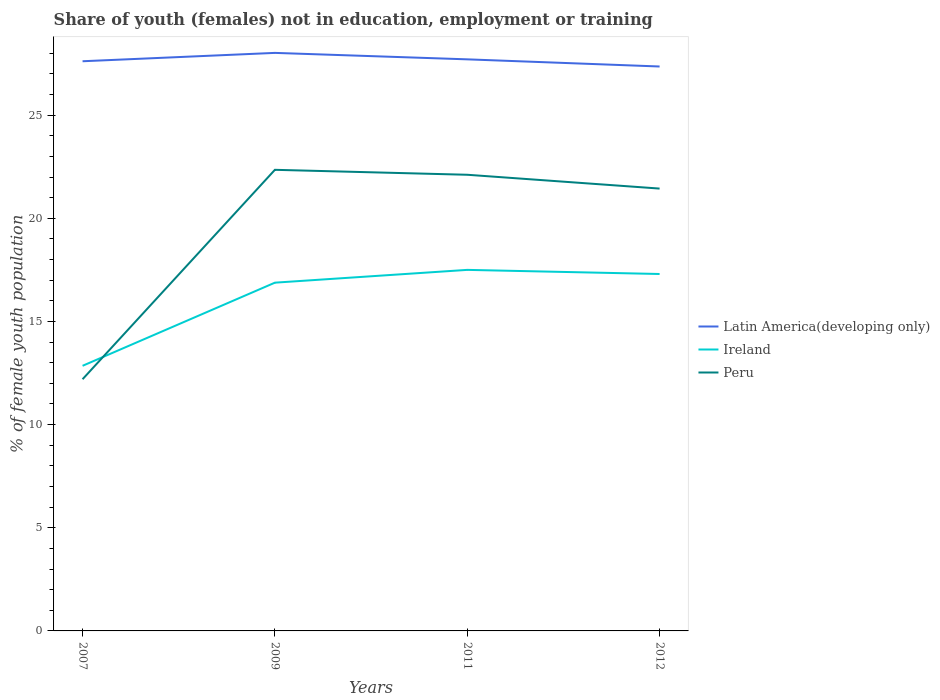Across all years, what is the maximum percentage of unemployed female population in in Ireland?
Your response must be concise. 12.85. What is the total percentage of unemployed female population in in Ireland in the graph?
Give a very brief answer. -4.45. What is the difference between the highest and the second highest percentage of unemployed female population in in Latin America(developing only)?
Give a very brief answer. 0.66. What is the difference between the highest and the lowest percentage of unemployed female population in in Ireland?
Make the answer very short. 3. How many lines are there?
Offer a terse response. 3. How many years are there in the graph?
Your answer should be very brief. 4. What is the difference between two consecutive major ticks on the Y-axis?
Ensure brevity in your answer.  5. Does the graph contain any zero values?
Keep it short and to the point. No. Where does the legend appear in the graph?
Provide a succinct answer. Center right. What is the title of the graph?
Your answer should be very brief. Share of youth (females) not in education, employment or training. What is the label or title of the Y-axis?
Provide a succinct answer. % of female youth population. What is the % of female youth population of Latin America(developing only) in 2007?
Provide a short and direct response. 27.61. What is the % of female youth population in Ireland in 2007?
Keep it short and to the point. 12.85. What is the % of female youth population in Peru in 2007?
Make the answer very short. 12.2. What is the % of female youth population in Latin America(developing only) in 2009?
Your answer should be compact. 28.02. What is the % of female youth population in Ireland in 2009?
Offer a terse response. 16.88. What is the % of female youth population of Peru in 2009?
Your response must be concise. 22.35. What is the % of female youth population in Latin America(developing only) in 2011?
Provide a succinct answer. 27.7. What is the % of female youth population of Ireland in 2011?
Your answer should be very brief. 17.5. What is the % of female youth population of Peru in 2011?
Offer a very short reply. 22.11. What is the % of female youth population in Latin America(developing only) in 2012?
Provide a short and direct response. 27.36. What is the % of female youth population of Ireland in 2012?
Your answer should be very brief. 17.3. What is the % of female youth population in Peru in 2012?
Provide a succinct answer. 21.44. Across all years, what is the maximum % of female youth population of Latin America(developing only)?
Your answer should be compact. 28.02. Across all years, what is the maximum % of female youth population in Peru?
Keep it short and to the point. 22.35. Across all years, what is the minimum % of female youth population of Latin America(developing only)?
Keep it short and to the point. 27.36. Across all years, what is the minimum % of female youth population in Ireland?
Keep it short and to the point. 12.85. Across all years, what is the minimum % of female youth population of Peru?
Keep it short and to the point. 12.2. What is the total % of female youth population of Latin America(developing only) in the graph?
Make the answer very short. 110.69. What is the total % of female youth population in Ireland in the graph?
Provide a short and direct response. 64.53. What is the total % of female youth population of Peru in the graph?
Your response must be concise. 78.1. What is the difference between the % of female youth population of Latin America(developing only) in 2007 and that in 2009?
Give a very brief answer. -0.4. What is the difference between the % of female youth population of Ireland in 2007 and that in 2009?
Keep it short and to the point. -4.03. What is the difference between the % of female youth population of Peru in 2007 and that in 2009?
Your response must be concise. -10.15. What is the difference between the % of female youth population of Latin America(developing only) in 2007 and that in 2011?
Keep it short and to the point. -0.09. What is the difference between the % of female youth population in Ireland in 2007 and that in 2011?
Provide a short and direct response. -4.65. What is the difference between the % of female youth population in Peru in 2007 and that in 2011?
Offer a terse response. -9.91. What is the difference between the % of female youth population in Latin America(developing only) in 2007 and that in 2012?
Your answer should be very brief. 0.25. What is the difference between the % of female youth population of Ireland in 2007 and that in 2012?
Your response must be concise. -4.45. What is the difference between the % of female youth population of Peru in 2007 and that in 2012?
Give a very brief answer. -9.24. What is the difference between the % of female youth population in Latin America(developing only) in 2009 and that in 2011?
Your answer should be very brief. 0.31. What is the difference between the % of female youth population of Ireland in 2009 and that in 2011?
Ensure brevity in your answer.  -0.62. What is the difference between the % of female youth population of Peru in 2009 and that in 2011?
Provide a short and direct response. 0.24. What is the difference between the % of female youth population in Latin America(developing only) in 2009 and that in 2012?
Provide a succinct answer. 0.66. What is the difference between the % of female youth population in Ireland in 2009 and that in 2012?
Give a very brief answer. -0.42. What is the difference between the % of female youth population in Peru in 2009 and that in 2012?
Give a very brief answer. 0.91. What is the difference between the % of female youth population of Latin America(developing only) in 2011 and that in 2012?
Your response must be concise. 0.35. What is the difference between the % of female youth population in Peru in 2011 and that in 2012?
Your response must be concise. 0.67. What is the difference between the % of female youth population in Latin America(developing only) in 2007 and the % of female youth population in Ireland in 2009?
Offer a terse response. 10.73. What is the difference between the % of female youth population of Latin America(developing only) in 2007 and the % of female youth population of Peru in 2009?
Keep it short and to the point. 5.26. What is the difference between the % of female youth population of Latin America(developing only) in 2007 and the % of female youth population of Ireland in 2011?
Ensure brevity in your answer.  10.11. What is the difference between the % of female youth population in Latin America(developing only) in 2007 and the % of female youth population in Peru in 2011?
Your answer should be compact. 5.5. What is the difference between the % of female youth population of Ireland in 2007 and the % of female youth population of Peru in 2011?
Offer a terse response. -9.26. What is the difference between the % of female youth population of Latin America(developing only) in 2007 and the % of female youth population of Ireland in 2012?
Your response must be concise. 10.31. What is the difference between the % of female youth population in Latin America(developing only) in 2007 and the % of female youth population in Peru in 2012?
Offer a terse response. 6.17. What is the difference between the % of female youth population in Ireland in 2007 and the % of female youth population in Peru in 2012?
Provide a succinct answer. -8.59. What is the difference between the % of female youth population of Latin America(developing only) in 2009 and the % of female youth population of Ireland in 2011?
Your answer should be very brief. 10.52. What is the difference between the % of female youth population in Latin America(developing only) in 2009 and the % of female youth population in Peru in 2011?
Your response must be concise. 5.91. What is the difference between the % of female youth population in Ireland in 2009 and the % of female youth population in Peru in 2011?
Give a very brief answer. -5.23. What is the difference between the % of female youth population of Latin America(developing only) in 2009 and the % of female youth population of Ireland in 2012?
Give a very brief answer. 10.72. What is the difference between the % of female youth population of Latin America(developing only) in 2009 and the % of female youth population of Peru in 2012?
Offer a very short reply. 6.58. What is the difference between the % of female youth population in Ireland in 2009 and the % of female youth population in Peru in 2012?
Your answer should be compact. -4.56. What is the difference between the % of female youth population of Latin America(developing only) in 2011 and the % of female youth population of Ireland in 2012?
Give a very brief answer. 10.4. What is the difference between the % of female youth population in Latin America(developing only) in 2011 and the % of female youth population in Peru in 2012?
Your answer should be compact. 6.26. What is the difference between the % of female youth population of Ireland in 2011 and the % of female youth population of Peru in 2012?
Your answer should be compact. -3.94. What is the average % of female youth population of Latin America(developing only) per year?
Your response must be concise. 27.67. What is the average % of female youth population in Ireland per year?
Offer a very short reply. 16.13. What is the average % of female youth population in Peru per year?
Ensure brevity in your answer.  19.52. In the year 2007, what is the difference between the % of female youth population of Latin America(developing only) and % of female youth population of Ireland?
Give a very brief answer. 14.76. In the year 2007, what is the difference between the % of female youth population of Latin America(developing only) and % of female youth population of Peru?
Your answer should be very brief. 15.41. In the year 2007, what is the difference between the % of female youth population of Ireland and % of female youth population of Peru?
Ensure brevity in your answer.  0.65. In the year 2009, what is the difference between the % of female youth population of Latin America(developing only) and % of female youth population of Ireland?
Offer a terse response. 11.14. In the year 2009, what is the difference between the % of female youth population in Latin America(developing only) and % of female youth population in Peru?
Provide a short and direct response. 5.67. In the year 2009, what is the difference between the % of female youth population in Ireland and % of female youth population in Peru?
Give a very brief answer. -5.47. In the year 2011, what is the difference between the % of female youth population in Latin America(developing only) and % of female youth population in Ireland?
Offer a very short reply. 10.2. In the year 2011, what is the difference between the % of female youth population of Latin America(developing only) and % of female youth population of Peru?
Give a very brief answer. 5.59. In the year 2011, what is the difference between the % of female youth population of Ireland and % of female youth population of Peru?
Provide a succinct answer. -4.61. In the year 2012, what is the difference between the % of female youth population in Latin America(developing only) and % of female youth population in Ireland?
Offer a very short reply. 10.06. In the year 2012, what is the difference between the % of female youth population in Latin America(developing only) and % of female youth population in Peru?
Your response must be concise. 5.92. In the year 2012, what is the difference between the % of female youth population in Ireland and % of female youth population in Peru?
Make the answer very short. -4.14. What is the ratio of the % of female youth population in Latin America(developing only) in 2007 to that in 2009?
Make the answer very short. 0.99. What is the ratio of the % of female youth population in Ireland in 2007 to that in 2009?
Provide a short and direct response. 0.76. What is the ratio of the % of female youth population in Peru in 2007 to that in 2009?
Your answer should be very brief. 0.55. What is the ratio of the % of female youth population in Ireland in 2007 to that in 2011?
Ensure brevity in your answer.  0.73. What is the ratio of the % of female youth population of Peru in 2007 to that in 2011?
Your response must be concise. 0.55. What is the ratio of the % of female youth population in Latin America(developing only) in 2007 to that in 2012?
Give a very brief answer. 1.01. What is the ratio of the % of female youth population of Ireland in 2007 to that in 2012?
Your response must be concise. 0.74. What is the ratio of the % of female youth population of Peru in 2007 to that in 2012?
Make the answer very short. 0.57. What is the ratio of the % of female youth population in Latin America(developing only) in 2009 to that in 2011?
Offer a terse response. 1.01. What is the ratio of the % of female youth population of Ireland in 2009 to that in 2011?
Offer a terse response. 0.96. What is the ratio of the % of female youth population in Peru in 2009 to that in 2011?
Keep it short and to the point. 1.01. What is the ratio of the % of female youth population of Latin America(developing only) in 2009 to that in 2012?
Give a very brief answer. 1.02. What is the ratio of the % of female youth population of Ireland in 2009 to that in 2012?
Provide a short and direct response. 0.98. What is the ratio of the % of female youth population of Peru in 2009 to that in 2012?
Make the answer very short. 1.04. What is the ratio of the % of female youth population in Latin America(developing only) in 2011 to that in 2012?
Offer a very short reply. 1.01. What is the ratio of the % of female youth population of Ireland in 2011 to that in 2012?
Keep it short and to the point. 1.01. What is the ratio of the % of female youth population in Peru in 2011 to that in 2012?
Keep it short and to the point. 1.03. What is the difference between the highest and the second highest % of female youth population in Latin America(developing only)?
Keep it short and to the point. 0.31. What is the difference between the highest and the second highest % of female youth population of Peru?
Your answer should be compact. 0.24. What is the difference between the highest and the lowest % of female youth population in Latin America(developing only)?
Make the answer very short. 0.66. What is the difference between the highest and the lowest % of female youth population of Ireland?
Give a very brief answer. 4.65. What is the difference between the highest and the lowest % of female youth population in Peru?
Your answer should be compact. 10.15. 